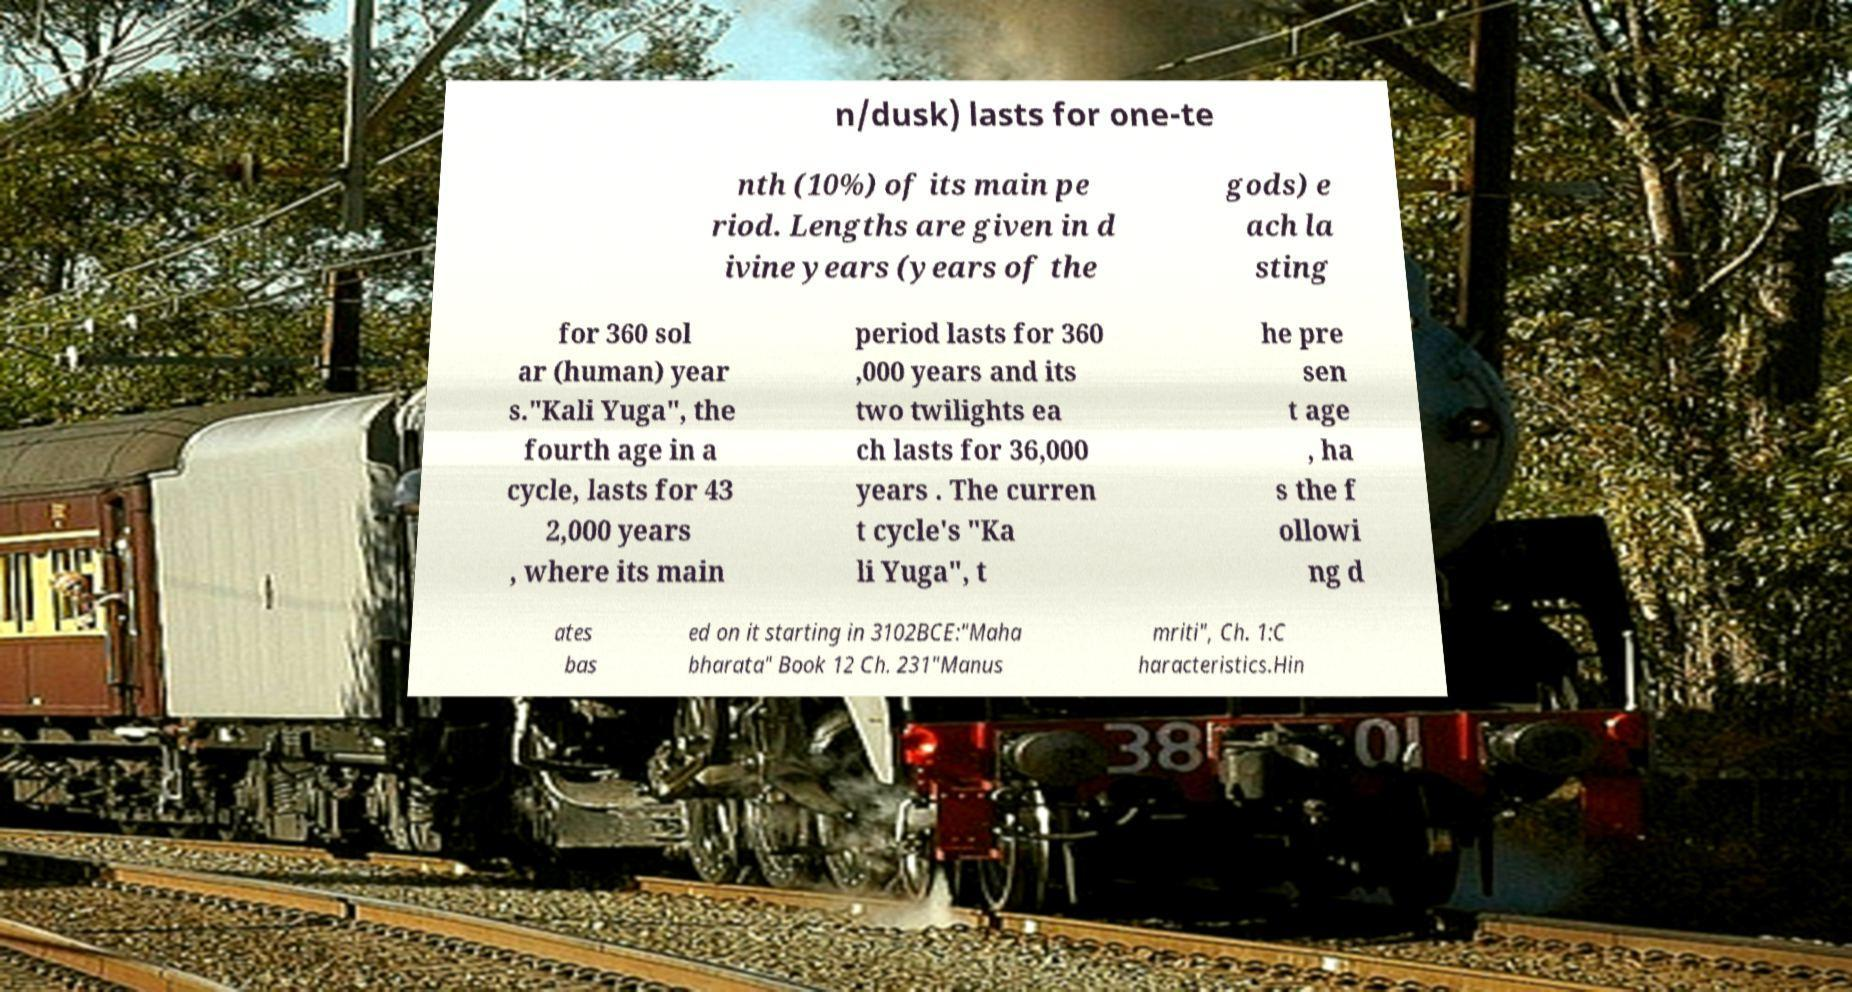I need the written content from this picture converted into text. Can you do that? n/dusk) lasts for one-te nth (10%) of its main pe riod. Lengths are given in d ivine years (years of the gods) e ach la sting for 360 sol ar (human) year s."Kali Yuga", the fourth age in a cycle, lasts for 43 2,000 years , where its main period lasts for 360 ,000 years and its two twilights ea ch lasts for 36,000 years . The curren t cycle's "Ka li Yuga", t he pre sen t age , ha s the f ollowi ng d ates bas ed on it starting in 3102BCE:"Maha bharata" Book 12 Ch. 231"Manus mriti", Ch. 1:C haracteristics.Hin 